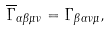<formula> <loc_0><loc_0><loc_500><loc_500>\overline { \Gamma } _ { \alpha \beta \mu \nu } = \Gamma _ { \beta \alpha \nu \mu } ,</formula> 